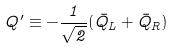Convert formula to latex. <formula><loc_0><loc_0><loc_500><loc_500>Q ^ { \prime } \equiv - \frac { 1 } { \sqrt { 2 } } ( \bar { Q } _ { L } + \bar { Q } _ { R } )</formula> 